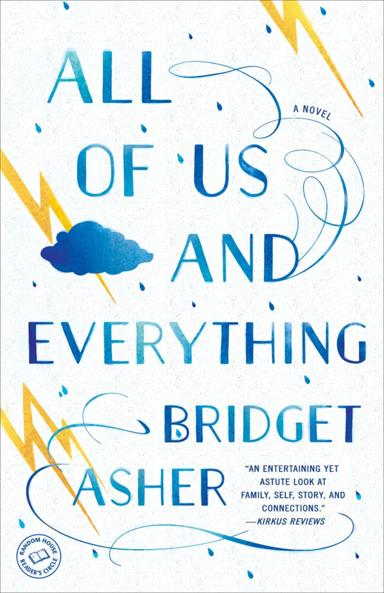What is the title of the novel mentioned in the image?
 The title of the novel is "All of Us and Everything" by Bridget Asher. What is the tone of the novel according to the review? According to the Kirkus Reviews, the novel is entertaining yet astute. What are the main themes of the novel mentioned in the image? The main themes of the novel mentioned in the image are family, self, story, and connections. 